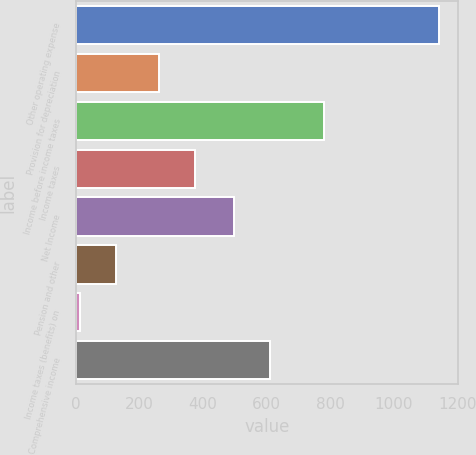<chart> <loc_0><loc_0><loc_500><loc_500><bar_chart><fcel>Other operating expense<fcel>Provision for depreciation<fcel>Income before income taxes<fcel>Income taxes<fcel>Net Income<fcel>Pension and other<fcel>Income taxes (benefits) on<fcel>Comprehensive income<nl><fcel>1143<fcel>262<fcel>779<fcel>374.9<fcel>498<fcel>126.9<fcel>14<fcel>610.9<nl></chart> 